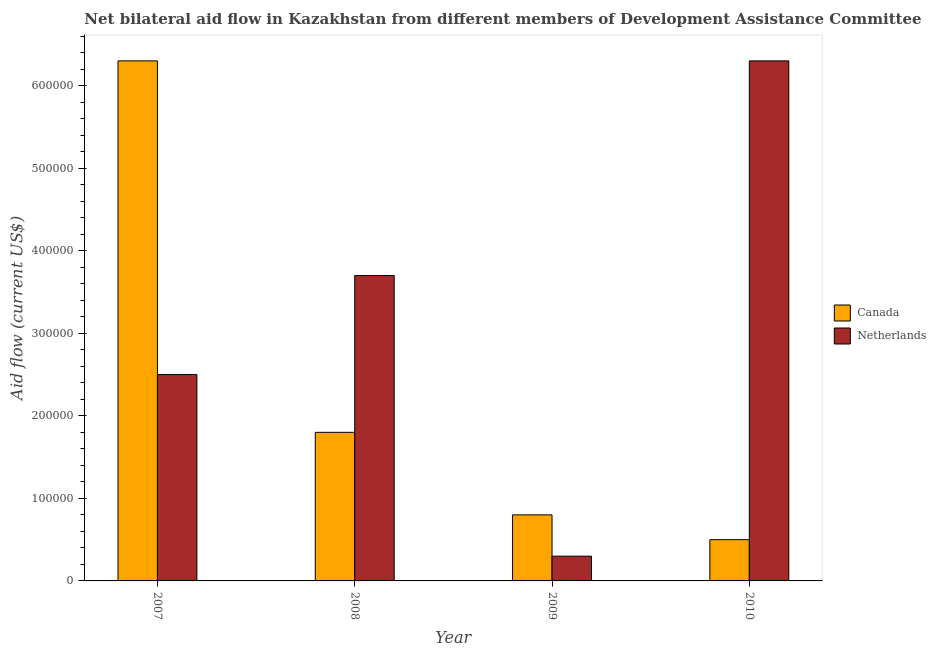How many different coloured bars are there?
Provide a short and direct response. 2. How many groups of bars are there?
Your response must be concise. 4. Are the number of bars per tick equal to the number of legend labels?
Provide a short and direct response. Yes. Are the number of bars on each tick of the X-axis equal?
Provide a short and direct response. Yes. How many bars are there on the 1st tick from the left?
Make the answer very short. 2. How many bars are there on the 4th tick from the right?
Provide a short and direct response. 2. What is the label of the 3rd group of bars from the left?
Your answer should be very brief. 2009. In how many cases, is the number of bars for a given year not equal to the number of legend labels?
Your answer should be compact. 0. What is the amount of aid given by netherlands in 2009?
Offer a very short reply. 3.00e+04. Across all years, what is the maximum amount of aid given by netherlands?
Make the answer very short. 6.30e+05. Across all years, what is the minimum amount of aid given by canada?
Provide a short and direct response. 5.00e+04. What is the total amount of aid given by netherlands in the graph?
Ensure brevity in your answer.  1.28e+06. What is the difference between the amount of aid given by canada in 2007 and that in 2009?
Offer a terse response. 5.50e+05. What is the difference between the amount of aid given by netherlands in 2008 and the amount of aid given by canada in 2007?
Your response must be concise. 1.20e+05. What is the average amount of aid given by canada per year?
Offer a terse response. 2.35e+05. What is the ratio of the amount of aid given by canada in 2007 to that in 2010?
Your response must be concise. 12.6. Is the difference between the amount of aid given by netherlands in 2008 and 2009 greater than the difference between the amount of aid given by canada in 2008 and 2009?
Give a very brief answer. No. What is the difference between the highest and the lowest amount of aid given by canada?
Offer a terse response. 5.80e+05. How many years are there in the graph?
Your answer should be compact. 4. What is the difference between two consecutive major ticks on the Y-axis?
Your response must be concise. 1.00e+05. What is the title of the graph?
Make the answer very short. Net bilateral aid flow in Kazakhstan from different members of Development Assistance Committee. Does "Male labourers" appear as one of the legend labels in the graph?
Make the answer very short. No. What is the Aid flow (current US$) of Canada in 2007?
Your response must be concise. 6.30e+05. What is the Aid flow (current US$) of Netherlands in 2007?
Offer a terse response. 2.50e+05. What is the Aid flow (current US$) of Canada in 2009?
Provide a succinct answer. 8.00e+04. What is the Aid flow (current US$) of Netherlands in 2009?
Provide a succinct answer. 3.00e+04. What is the Aid flow (current US$) of Canada in 2010?
Keep it short and to the point. 5.00e+04. What is the Aid flow (current US$) in Netherlands in 2010?
Your response must be concise. 6.30e+05. Across all years, what is the maximum Aid flow (current US$) of Canada?
Provide a succinct answer. 6.30e+05. Across all years, what is the maximum Aid flow (current US$) of Netherlands?
Make the answer very short. 6.30e+05. What is the total Aid flow (current US$) in Canada in the graph?
Your answer should be very brief. 9.40e+05. What is the total Aid flow (current US$) of Netherlands in the graph?
Your response must be concise. 1.28e+06. What is the difference between the Aid flow (current US$) in Canada in 2007 and that in 2008?
Give a very brief answer. 4.50e+05. What is the difference between the Aid flow (current US$) in Netherlands in 2007 and that in 2008?
Give a very brief answer. -1.20e+05. What is the difference between the Aid flow (current US$) of Canada in 2007 and that in 2009?
Ensure brevity in your answer.  5.50e+05. What is the difference between the Aid flow (current US$) of Canada in 2007 and that in 2010?
Ensure brevity in your answer.  5.80e+05. What is the difference between the Aid flow (current US$) in Netherlands in 2007 and that in 2010?
Offer a terse response. -3.80e+05. What is the difference between the Aid flow (current US$) of Netherlands in 2008 and that in 2009?
Keep it short and to the point. 3.40e+05. What is the difference between the Aid flow (current US$) of Canada in 2008 and that in 2010?
Provide a succinct answer. 1.30e+05. What is the difference between the Aid flow (current US$) of Canada in 2009 and that in 2010?
Provide a succinct answer. 3.00e+04. What is the difference between the Aid flow (current US$) of Netherlands in 2009 and that in 2010?
Ensure brevity in your answer.  -6.00e+05. What is the difference between the Aid flow (current US$) in Canada in 2008 and the Aid flow (current US$) in Netherlands in 2010?
Ensure brevity in your answer.  -4.50e+05. What is the difference between the Aid flow (current US$) in Canada in 2009 and the Aid flow (current US$) in Netherlands in 2010?
Provide a succinct answer. -5.50e+05. What is the average Aid flow (current US$) of Canada per year?
Ensure brevity in your answer.  2.35e+05. In the year 2010, what is the difference between the Aid flow (current US$) of Canada and Aid flow (current US$) of Netherlands?
Your answer should be compact. -5.80e+05. What is the ratio of the Aid flow (current US$) of Netherlands in 2007 to that in 2008?
Provide a short and direct response. 0.68. What is the ratio of the Aid flow (current US$) of Canada in 2007 to that in 2009?
Ensure brevity in your answer.  7.88. What is the ratio of the Aid flow (current US$) in Netherlands in 2007 to that in 2009?
Make the answer very short. 8.33. What is the ratio of the Aid flow (current US$) of Canada in 2007 to that in 2010?
Offer a very short reply. 12.6. What is the ratio of the Aid flow (current US$) of Netherlands in 2007 to that in 2010?
Give a very brief answer. 0.4. What is the ratio of the Aid flow (current US$) of Canada in 2008 to that in 2009?
Offer a terse response. 2.25. What is the ratio of the Aid flow (current US$) in Netherlands in 2008 to that in 2009?
Your answer should be compact. 12.33. What is the ratio of the Aid flow (current US$) in Canada in 2008 to that in 2010?
Your response must be concise. 3.6. What is the ratio of the Aid flow (current US$) in Netherlands in 2008 to that in 2010?
Provide a succinct answer. 0.59. What is the ratio of the Aid flow (current US$) of Netherlands in 2009 to that in 2010?
Your answer should be compact. 0.05. What is the difference between the highest and the second highest Aid flow (current US$) in Canada?
Keep it short and to the point. 4.50e+05. What is the difference between the highest and the lowest Aid flow (current US$) of Canada?
Offer a terse response. 5.80e+05. What is the difference between the highest and the lowest Aid flow (current US$) of Netherlands?
Provide a short and direct response. 6.00e+05. 